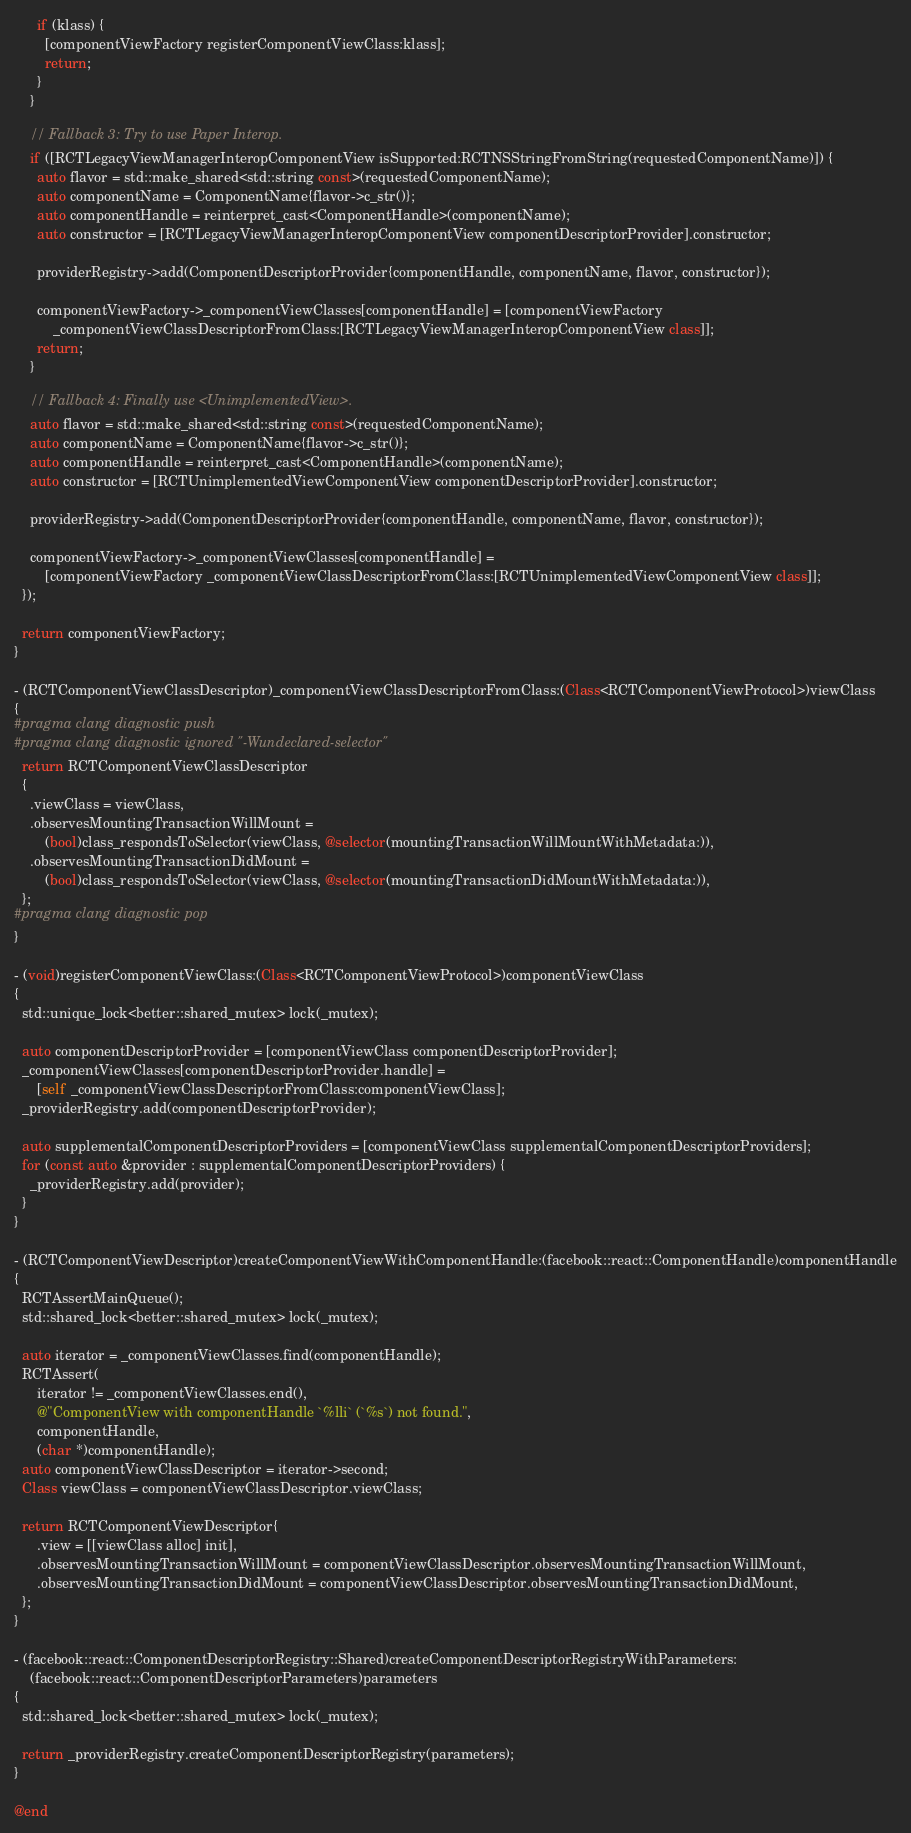Convert code to text. <code><loc_0><loc_0><loc_500><loc_500><_ObjectiveC_>      if (klass) {
        [componentViewFactory registerComponentViewClass:klass];
        return;
      }
    }

    // Fallback 3: Try to use Paper Interop.
    if ([RCTLegacyViewManagerInteropComponentView isSupported:RCTNSStringFromString(requestedComponentName)]) {
      auto flavor = std::make_shared<std::string const>(requestedComponentName);
      auto componentName = ComponentName{flavor->c_str()};
      auto componentHandle = reinterpret_cast<ComponentHandle>(componentName);
      auto constructor = [RCTLegacyViewManagerInteropComponentView componentDescriptorProvider].constructor;

      providerRegistry->add(ComponentDescriptorProvider{componentHandle, componentName, flavor, constructor});

      componentViewFactory->_componentViewClasses[componentHandle] = [componentViewFactory
          _componentViewClassDescriptorFromClass:[RCTLegacyViewManagerInteropComponentView class]];
      return;
    }

    // Fallback 4: Finally use <UnimplementedView>.
    auto flavor = std::make_shared<std::string const>(requestedComponentName);
    auto componentName = ComponentName{flavor->c_str()};
    auto componentHandle = reinterpret_cast<ComponentHandle>(componentName);
    auto constructor = [RCTUnimplementedViewComponentView componentDescriptorProvider].constructor;

    providerRegistry->add(ComponentDescriptorProvider{componentHandle, componentName, flavor, constructor});

    componentViewFactory->_componentViewClasses[componentHandle] =
        [componentViewFactory _componentViewClassDescriptorFromClass:[RCTUnimplementedViewComponentView class]];
  });

  return componentViewFactory;
}

- (RCTComponentViewClassDescriptor)_componentViewClassDescriptorFromClass:(Class<RCTComponentViewProtocol>)viewClass
{
#pragma clang diagnostic push
#pragma clang diagnostic ignored "-Wundeclared-selector"
  return RCTComponentViewClassDescriptor
  {
    .viewClass = viewClass,
    .observesMountingTransactionWillMount =
        (bool)class_respondsToSelector(viewClass, @selector(mountingTransactionWillMountWithMetadata:)),
    .observesMountingTransactionDidMount =
        (bool)class_respondsToSelector(viewClass, @selector(mountingTransactionDidMountWithMetadata:)),
  };
#pragma clang diagnostic pop
}

- (void)registerComponentViewClass:(Class<RCTComponentViewProtocol>)componentViewClass
{
  std::unique_lock<better::shared_mutex> lock(_mutex);

  auto componentDescriptorProvider = [componentViewClass componentDescriptorProvider];
  _componentViewClasses[componentDescriptorProvider.handle] =
      [self _componentViewClassDescriptorFromClass:componentViewClass];
  _providerRegistry.add(componentDescriptorProvider);

  auto supplementalComponentDescriptorProviders = [componentViewClass supplementalComponentDescriptorProviders];
  for (const auto &provider : supplementalComponentDescriptorProviders) {
    _providerRegistry.add(provider);
  }
}

- (RCTComponentViewDescriptor)createComponentViewWithComponentHandle:(facebook::react::ComponentHandle)componentHandle
{
  RCTAssertMainQueue();
  std::shared_lock<better::shared_mutex> lock(_mutex);

  auto iterator = _componentViewClasses.find(componentHandle);
  RCTAssert(
      iterator != _componentViewClasses.end(),
      @"ComponentView with componentHandle `%lli` (`%s`) not found.",
      componentHandle,
      (char *)componentHandle);
  auto componentViewClassDescriptor = iterator->second;
  Class viewClass = componentViewClassDescriptor.viewClass;

  return RCTComponentViewDescriptor{
      .view = [[viewClass alloc] init],
      .observesMountingTransactionWillMount = componentViewClassDescriptor.observesMountingTransactionWillMount,
      .observesMountingTransactionDidMount = componentViewClassDescriptor.observesMountingTransactionDidMount,
  };
}

- (facebook::react::ComponentDescriptorRegistry::Shared)createComponentDescriptorRegistryWithParameters:
    (facebook::react::ComponentDescriptorParameters)parameters
{
  std::shared_lock<better::shared_mutex> lock(_mutex);

  return _providerRegistry.createComponentDescriptorRegistry(parameters);
}

@end
</code> 